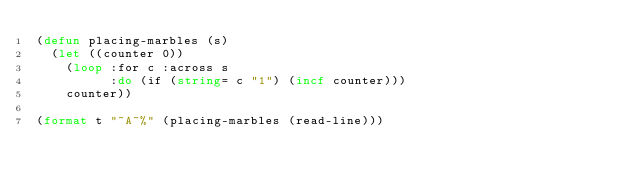Convert code to text. <code><loc_0><loc_0><loc_500><loc_500><_Lisp_>(defun placing-marbles (s)
  (let ((counter 0))
    (loop :for c :across s
          :do (if (string= c "1") (incf counter)))
    counter))

(format t "~A~%" (placing-marbles (read-line)))</code> 